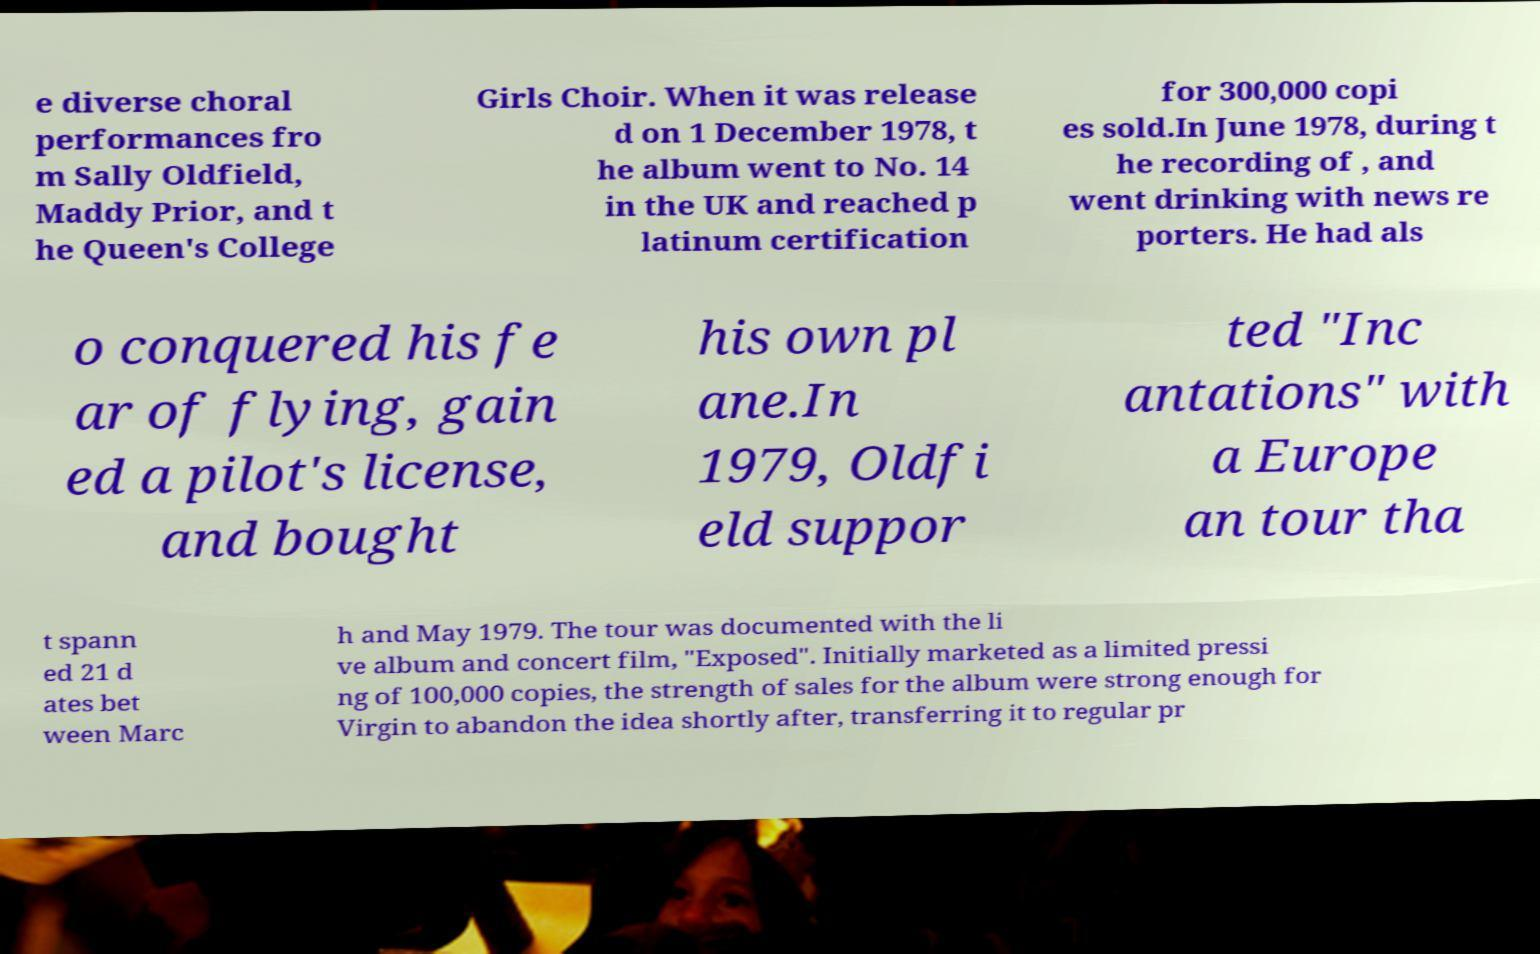Could you extract and type out the text from this image? e diverse choral performances fro m Sally Oldfield, Maddy Prior, and t he Queen's College Girls Choir. When it was release d on 1 December 1978, t he album went to No. 14 in the UK and reached p latinum certification for 300,000 copi es sold.In June 1978, during t he recording of , and went drinking with news re porters. He had als o conquered his fe ar of flying, gain ed a pilot's license, and bought his own pl ane.In 1979, Oldfi eld suppor ted "Inc antations" with a Europe an tour tha t spann ed 21 d ates bet ween Marc h and May 1979. The tour was documented with the li ve album and concert film, "Exposed". Initially marketed as a limited pressi ng of 100,000 copies, the strength of sales for the album were strong enough for Virgin to abandon the idea shortly after, transferring it to regular pr 